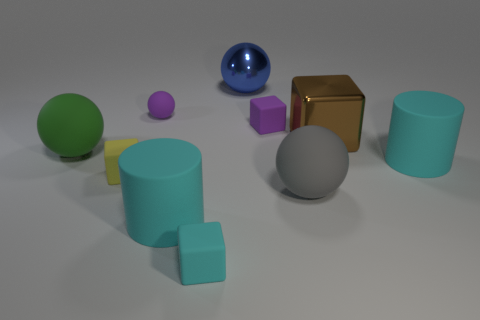Subtract all large green balls. How many balls are left? 3 Subtract all cylinders. How many objects are left? 8 Subtract all gray balls. How many balls are left? 3 Subtract 2 spheres. How many spheres are left? 2 Subtract all large red matte things. Subtract all cyan matte things. How many objects are left? 7 Add 9 metal blocks. How many metal blocks are left? 10 Add 3 yellow matte cubes. How many yellow matte cubes exist? 4 Subtract 0 cyan spheres. How many objects are left? 10 Subtract all gray blocks. Subtract all brown balls. How many blocks are left? 4 